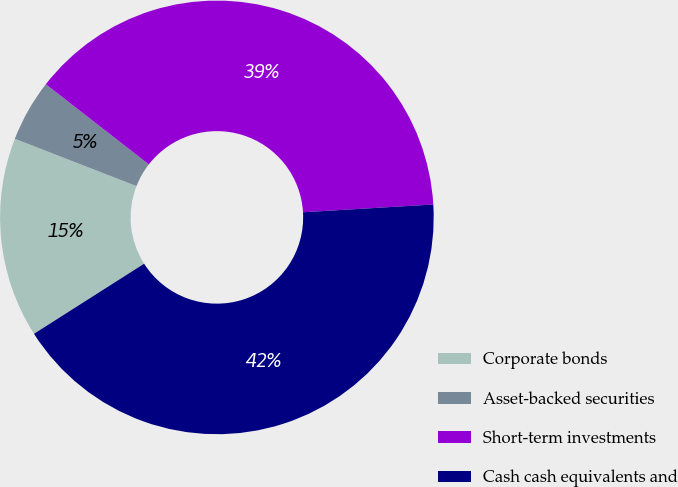Convert chart. <chart><loc_0><loc_0><loc_500><loc_500><pie_chart><fcel>Corporate bonds<fcel>Asset-backed securities<fcel>Short-term investments<fcel>Cash cash equivalents and<nl><fcel>14.93%<fcel>4.62%<fcel>38.53%<fcel>41.93%<nl></chart> 